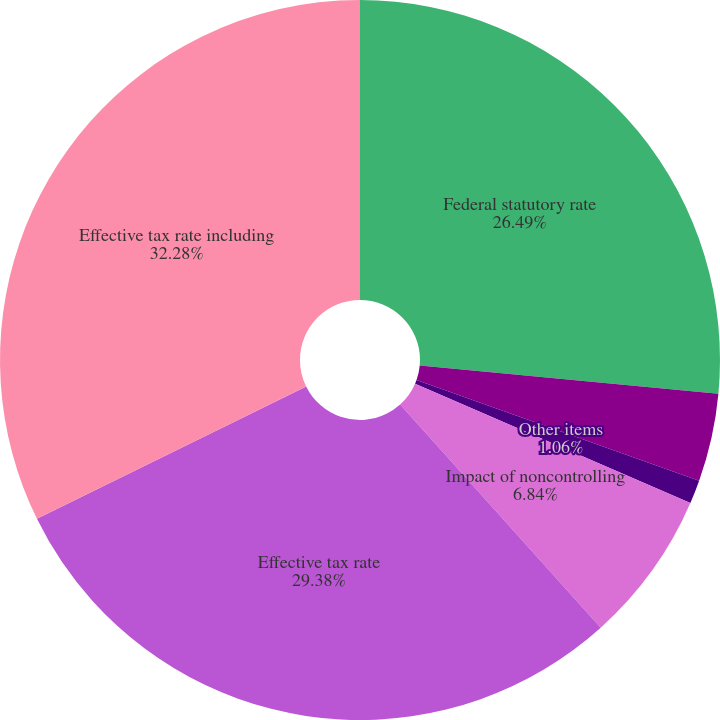Convert chart. <chart><loc_0><loc_0><loc_500><loc_500><pie_chart><fcel>Federal statutory rate<fcel>State taxes net of federal<fcel>Other items<fcel>Impact of noncontrolling<fcel>Effective tax rate<fcel>Effective tax rate including<nl><fcel>26.49%<fcel>3.95%<fcel>1.06%<fcel>6.84%<fcel>29.38%<fcel>32.27%<nl></chart> 